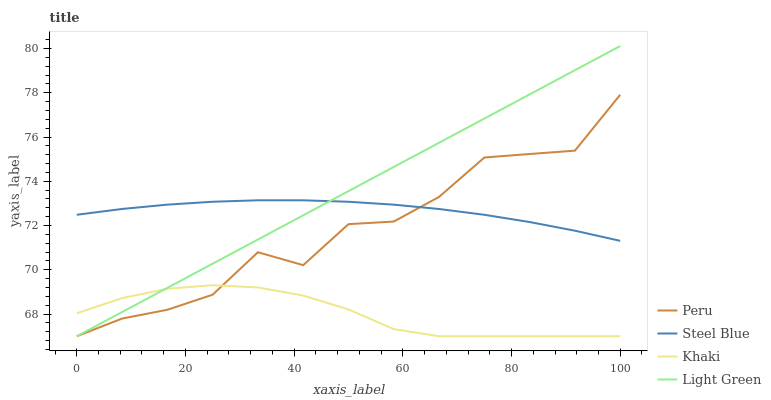Does Khaki have the minimum area under the curve?
Answer yes or no. Yes. Does Light Green have the maximum area under the curve?
Answer yes or no. Yes. Does Steel Blue have the minimum area under the curve?
Answer yes or no. No. Does Steel Blue have the maximum area under the curve?
Answer yes or no. No. Is Light Green the smoothest?
Answer yes or no. Yes. Is Peru the roughest?
Answer yes or no. Yes. Is Khaki the smoothest?
Answer yes or no. No. Is Khaki the roughest?
Answer yes or no. No. Does Light Green have the lowest value?
Answer yes or no. Yes. Does Steel Blue have the lowest value?
Answer yes or no. No. Does Light Green have the highest value?
Answer yes or no. Yes. Does Steel Blue have the highest value?
Answer yes or no. No. Is Khaki less than Steel Blue?
Answer yes or no. Yes. Is Steel Blue greater than Khaki?
Answer yes or no. Yes. Does Light Green intersect Peru?
Answer yes or no. Yes. Is Light Green less than Peru?
Answer yes or no. No. Is Light Green greater than Peru?
Answer yes or no. No. Does Khaki intersect Steel Blue?
Answer yes or no. No. 